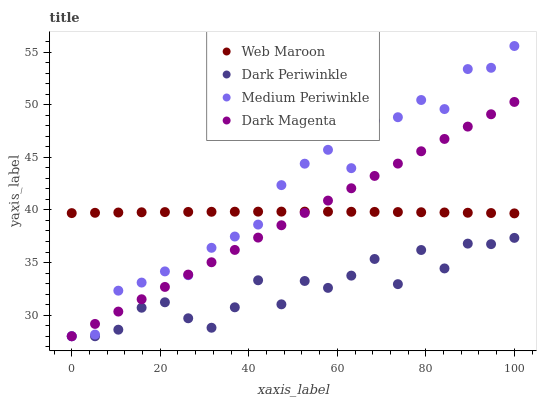Does Dark Periwinkle have the minimum area under the curve?
Answer yes or no. Yes. Does Medium Periwinkle have the maximum area under the curve?
Answer yes or no. Yes. Does Web Maroon have the minimum area under the curve?
Answer yes or no. No. Does Web Maroon have the maximum area under the curve?
Answer yes or no. No. Is Dark Magenta the smoothest?
Answer yes or no. Yes. Is Medium Periwinkle the roughest?
Answer yes or no. Yes. Is Web Maroon the smoothest?
Answer yes or no. No. Is Web Maroon the roughest?
Answer yes or no. No. Does Medium Periwinkle have the lowest value?
Answer yes or no. Yes. Does Web Maroon have the lowest value?
Answer yes or no. No. Does Medium Periwinkle have the highest value?
Answer yes or no. Yes. Does Web Maroon have the highest value?
Answer yes or no. No. Is Dark Periwinkle less than Web Maroon?
Answer yes or no. Yes. Is Web Maroon greater than Dark Periwinkle?
Answer yes or no. Yes. Does Dark Periwinkle intersect Medium Periwinkle?
Answer yes or no. Yes. Is Dark Periwinkle less than Medium Periwinkle?
Answer yes or no. No. Is Dark Periwinkle greater than Medium Periwinkle?
Answer yes or no. No. Does Dark Periwinkle intersect Web Maroon?
Answer yes or no. No. 